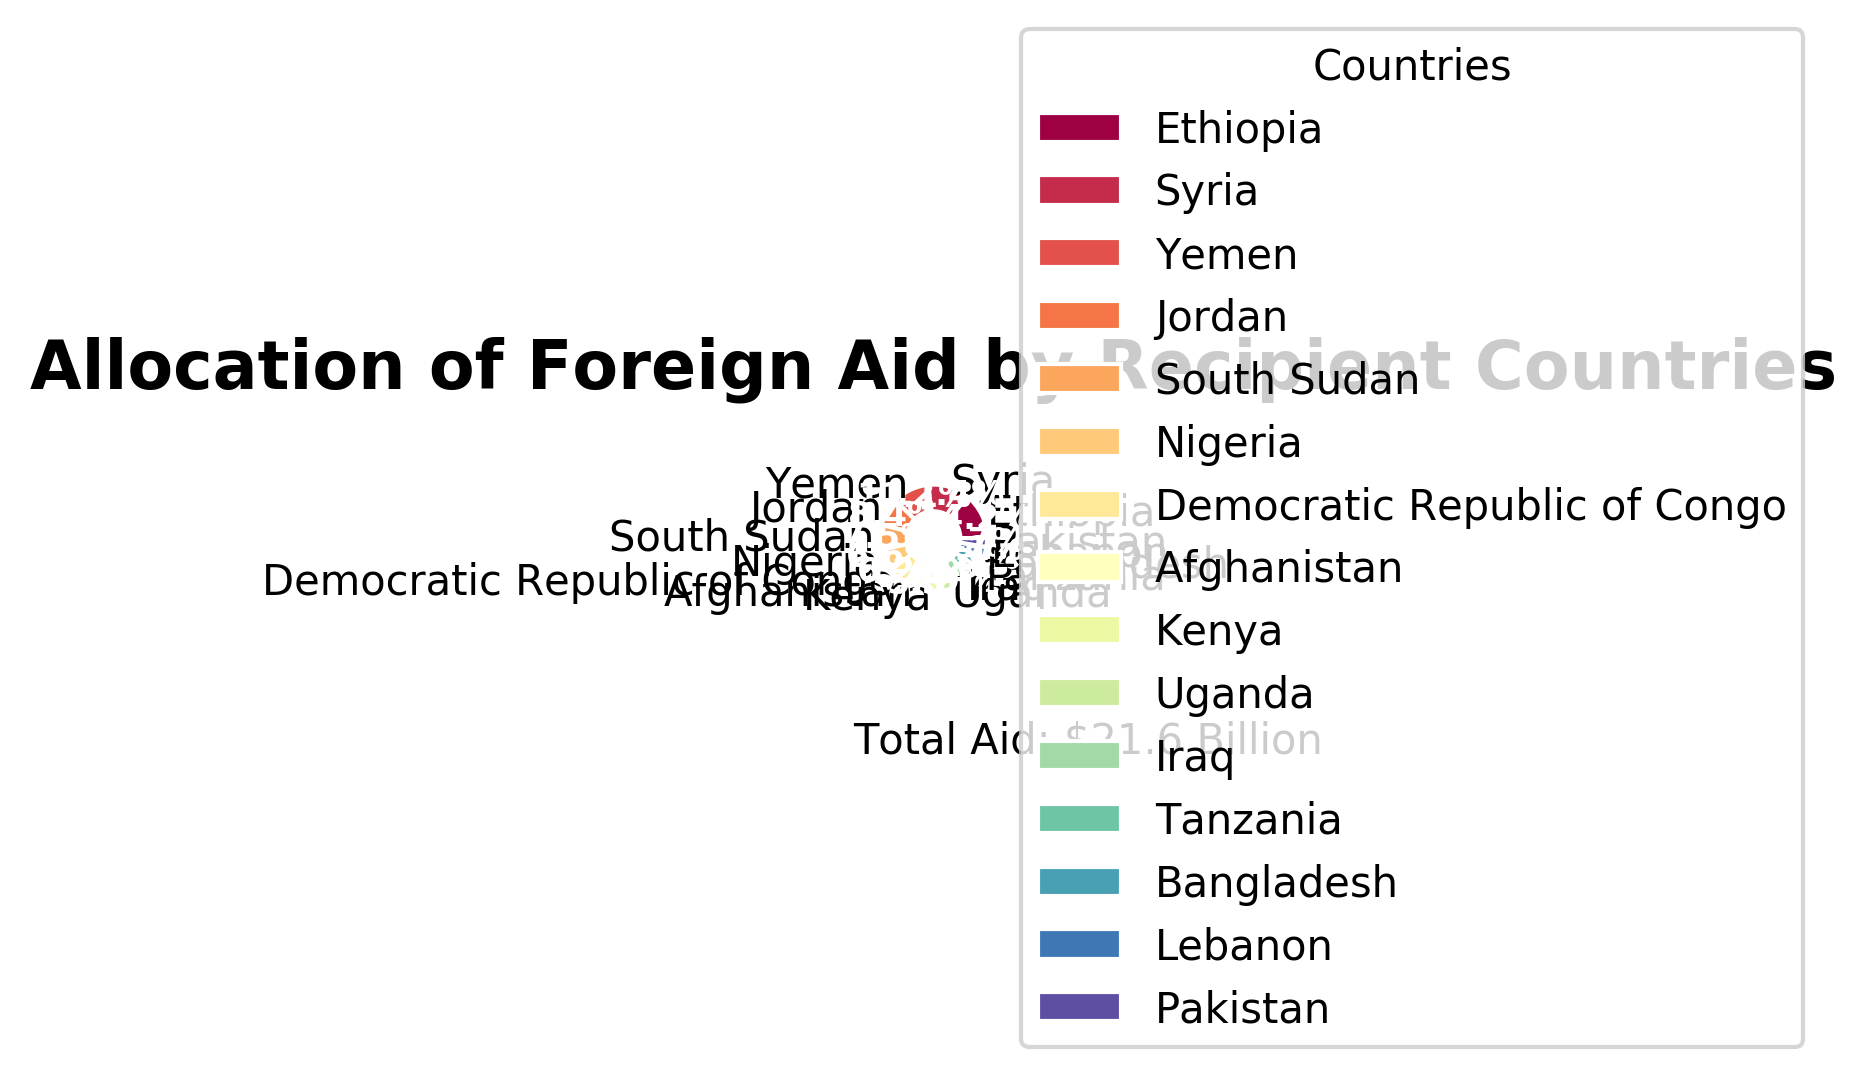Which country receives the largest share of foreign aid? By examining the pie chart, it's clear that the slice representing Ethiopia is the largest. Therefore, Ethiopia receives the largest share of foreign aid.
Answer: Ethiopia What percentage of total foreign aid does Tanzania receive? From the pie chart, locate the slice labeled Tanzania and its corresponding percentage. Tanzania receives 0.9 billion USD, which is 4.1% of the total.
Answer: 4.1% How much more aid does Ethiopia receive compared to Nigeria? Ethiopia receives 3.2 billion USD and Nigeria receives 1.5 billion USD. The difference is calculated as 3.2 - 1.5 = 1.7 billion USD.
Answer: 1.7 billion USD Which countries receive less than 1% of total foreign aid each? Observing the slices in the pie chart, Bangladesh, Lebanon, and Pakistan are the countries receiving less than 1% each.
Answer: Bangladesh, Lebanon, Pakistan What is the combined share of foreign aid for Syria and Yemen? Syria receives 2.8 billion USD and Yemen receives 2.5 billion USD. Combining their shares, (2.8 + 2.5) / 21.6 * 100 = 24.5%.
Answer: 24.5% Are there more countries receiving 0.9 billion USD or fewer than those receiving more than 0.9 billion USD? Count the slices for countries receiving 0.9 billion USD or less (Bangladesh, Lebanon, Pakistan, Tanzania, Uganda) and those receiving more than 0.9 billion USD. Fewer countries receive 0.9 billion USD or less (5) compared to those receiving more (10).
Answer: More Which country receives approximately twice as much aid as Afghanistan? Afghanistan receives 1.3 billion USD. Kenya receives 1.2 billion USD. By inspecting the amounts, no country receives exactly twice, but Ethiopia (3.2 billion USD) is close with a ratio of 3.2/1.3 ≈ 2.46.
Answer: Ethiopia What is the total amount of aid received by the top three recipient countries? The top three recipient countries are Ethiopia (3.2 billion USD), Syria (2.8 billion USD), and Yemen (2.5 billion USD). Summing these amounts: 3.2 + 2.8 + 2.5 = 8.5 billion USD.
Answer: 8.5 billion USD Which country is represented with the color at the middle of the spectrum? Observing the pie chart, the colors transition smoothly from one end of the spectrum to the other. Jordan, positioned roughly in the middle of the countries, usually falls at the middle of the color spectrum.
Answer: Jordan What is the ratio of aid received by Jordan to that received by Afghanistan? Jordan receives 1.9 billion USD while Afghanistan receives 1.3 billion USD. The ratio is 1.9 / 1.3 = 1.46.
Answer: 1.46 